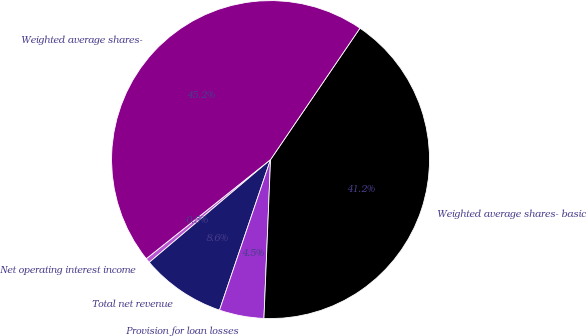<chart> <loc_0><loc_0><loc_500><loc_500><pie_chart><fcel>Net operating interest income<fcel>Total net revenue<fcel>Provision for loan losses<fcel>Weighted average shares- basic<fcel>Weighted average shares-<nl><fcel>0.47%<fcel>8.61%<fcel>4.54%<fcel>41.15%<fcel>45.22%<nl></chart> 